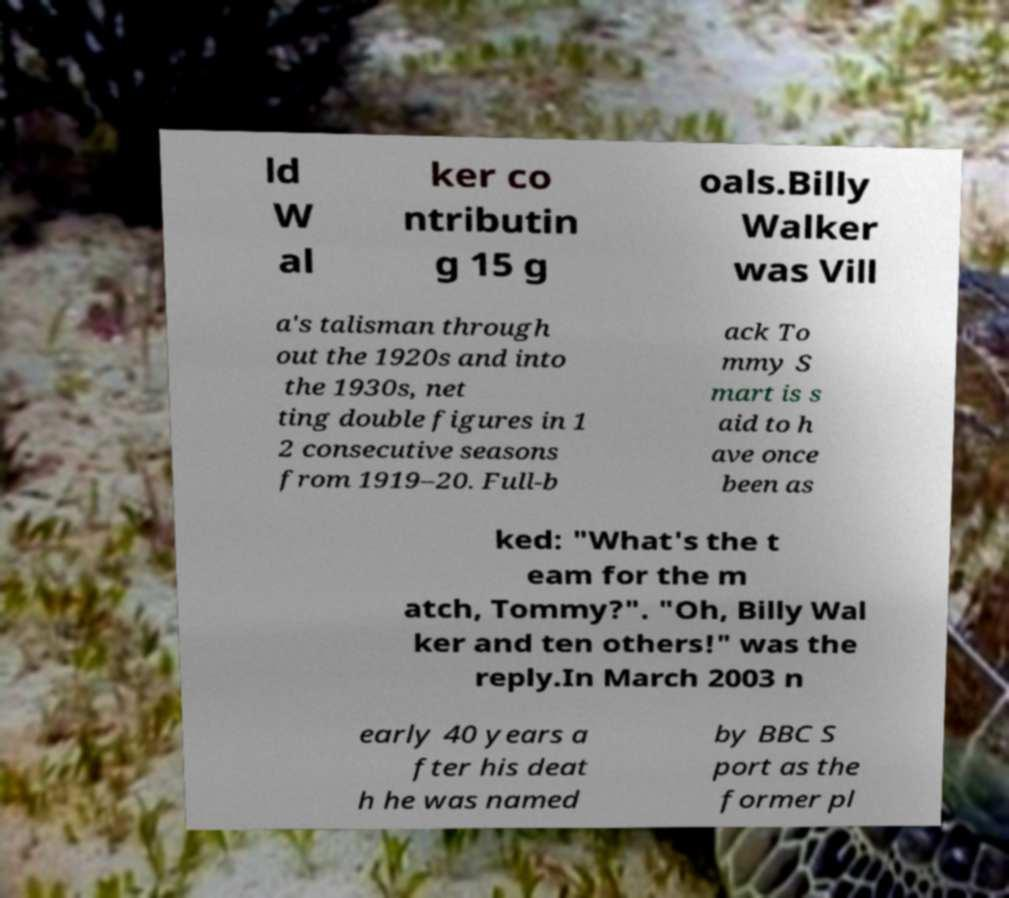Can you accurately transcribe the text from the provided image for me? ld W al ker co ntributin g 15 g oals.Billy Walker was Vill a's talisman through out the 1920s and into the 1930s, net ting double figures in 1 2 consecutive seasons from 1919–20. Full-b ack To mmy S mart is s aid to h ave once been as ked: "What's the t eam for the m atch, Tommy?". "Oh, Billy Wal ker and ten others!" was the reply.In March 2003 n early 40 years a fter his deat h he was named by BBC S port as the former pl 